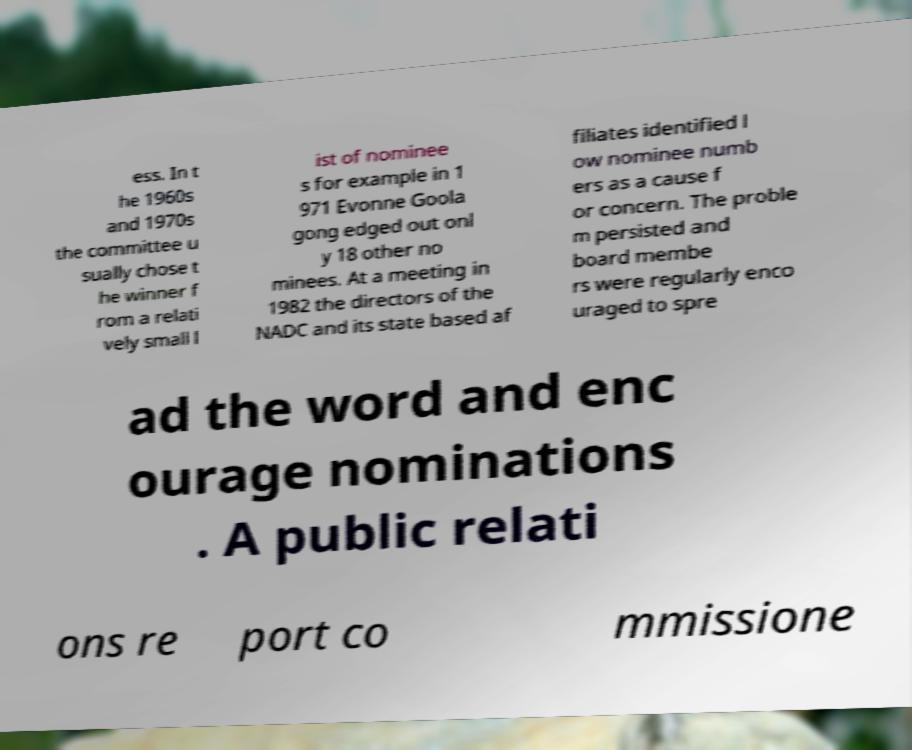Please identify and transcribe the text found in this image. ess. In t he 1960s and 1970s the committee u sually chose t he winner f rom a relati vely small l ist of nominee s for example in 1 971 Evonne Goola gong edged out onl y 18 other no minees. At a meeting in 1982 the directors of the NADC and its state based af filiates identified l ow nominee numb ers as a cause f or concern. The proble m persisted and board membe rs were regularly enco uraged to spre ad the word and enc ourage nominations . A public relati ons re port co mmissione 